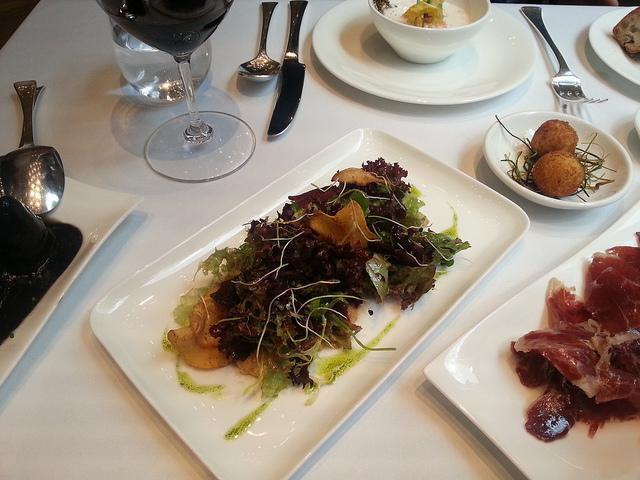How many spoons are on the table?
Give a very brief answer. 2. How many bowls are there?
Give a very brief answer. 2. How many people are riding?
Give a very brief answer. 0. 